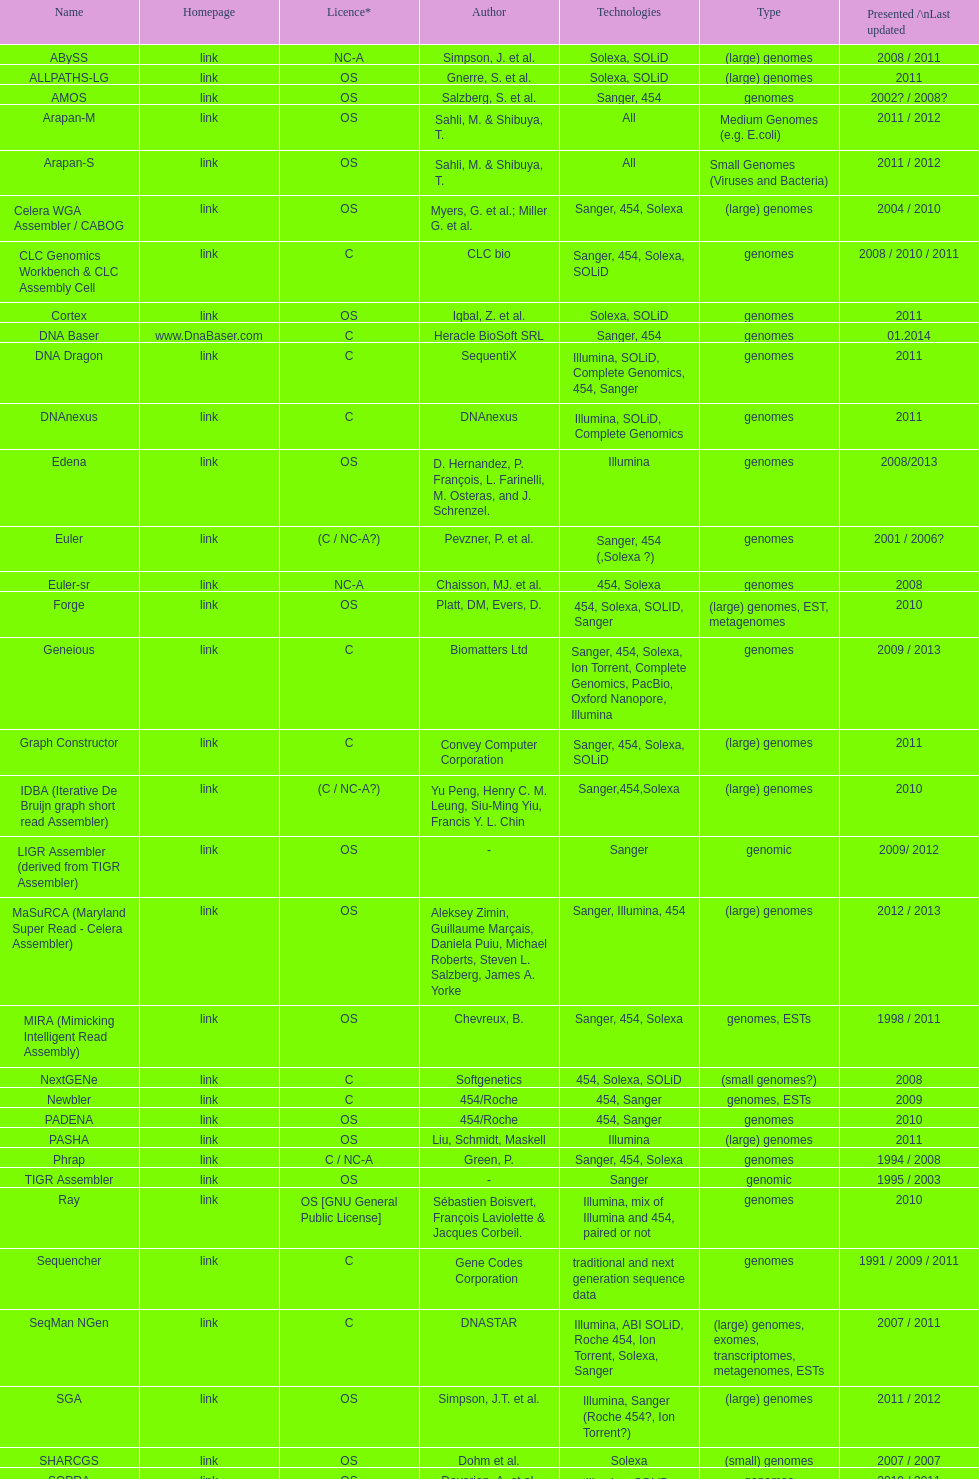What is the total number of assemblers supporting small genomes type technologies? 9. 